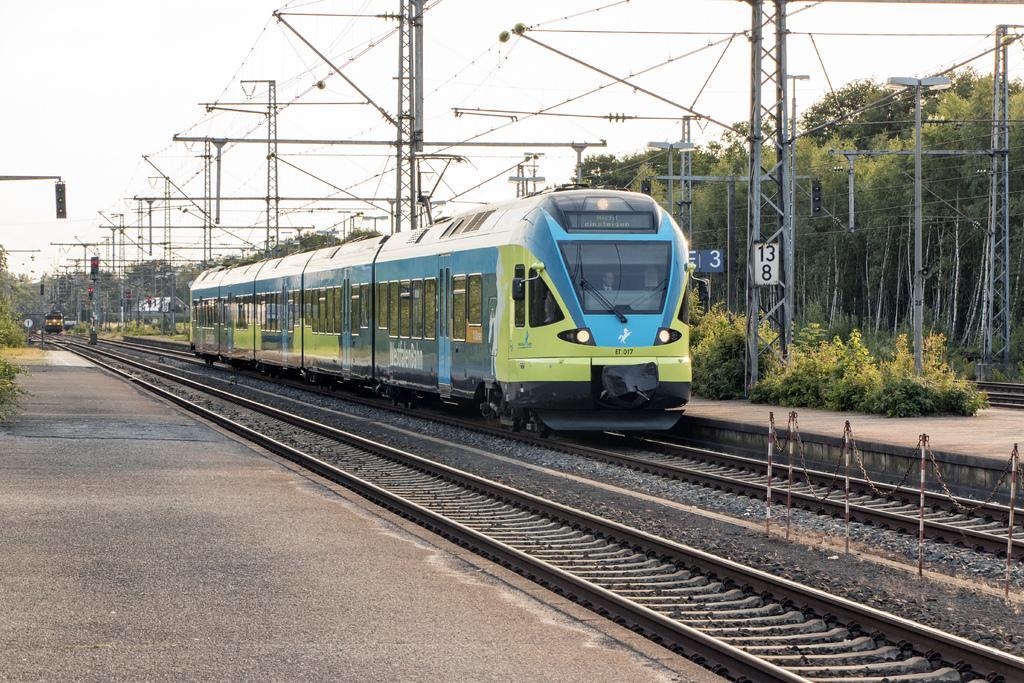Can you describe this image briefly? It is a train moving on the railway track, it is in blue color. On the left side it is a platform, on the right side there are green trees. At the top it is the sky. 